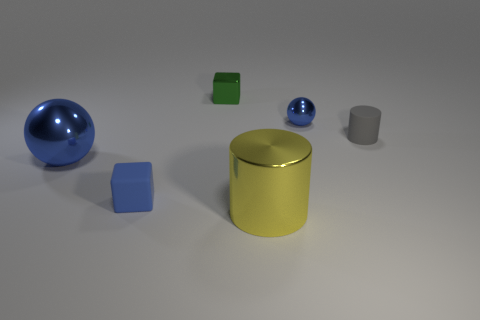What shapes do you see in the image? I see a large blue sphere, a smaller blue sphere, a green cube, a yellow cylinder, a silver-gray cylinder, and a blue cube. There's a variety of geometric shapes that create a visually interesting composition. 